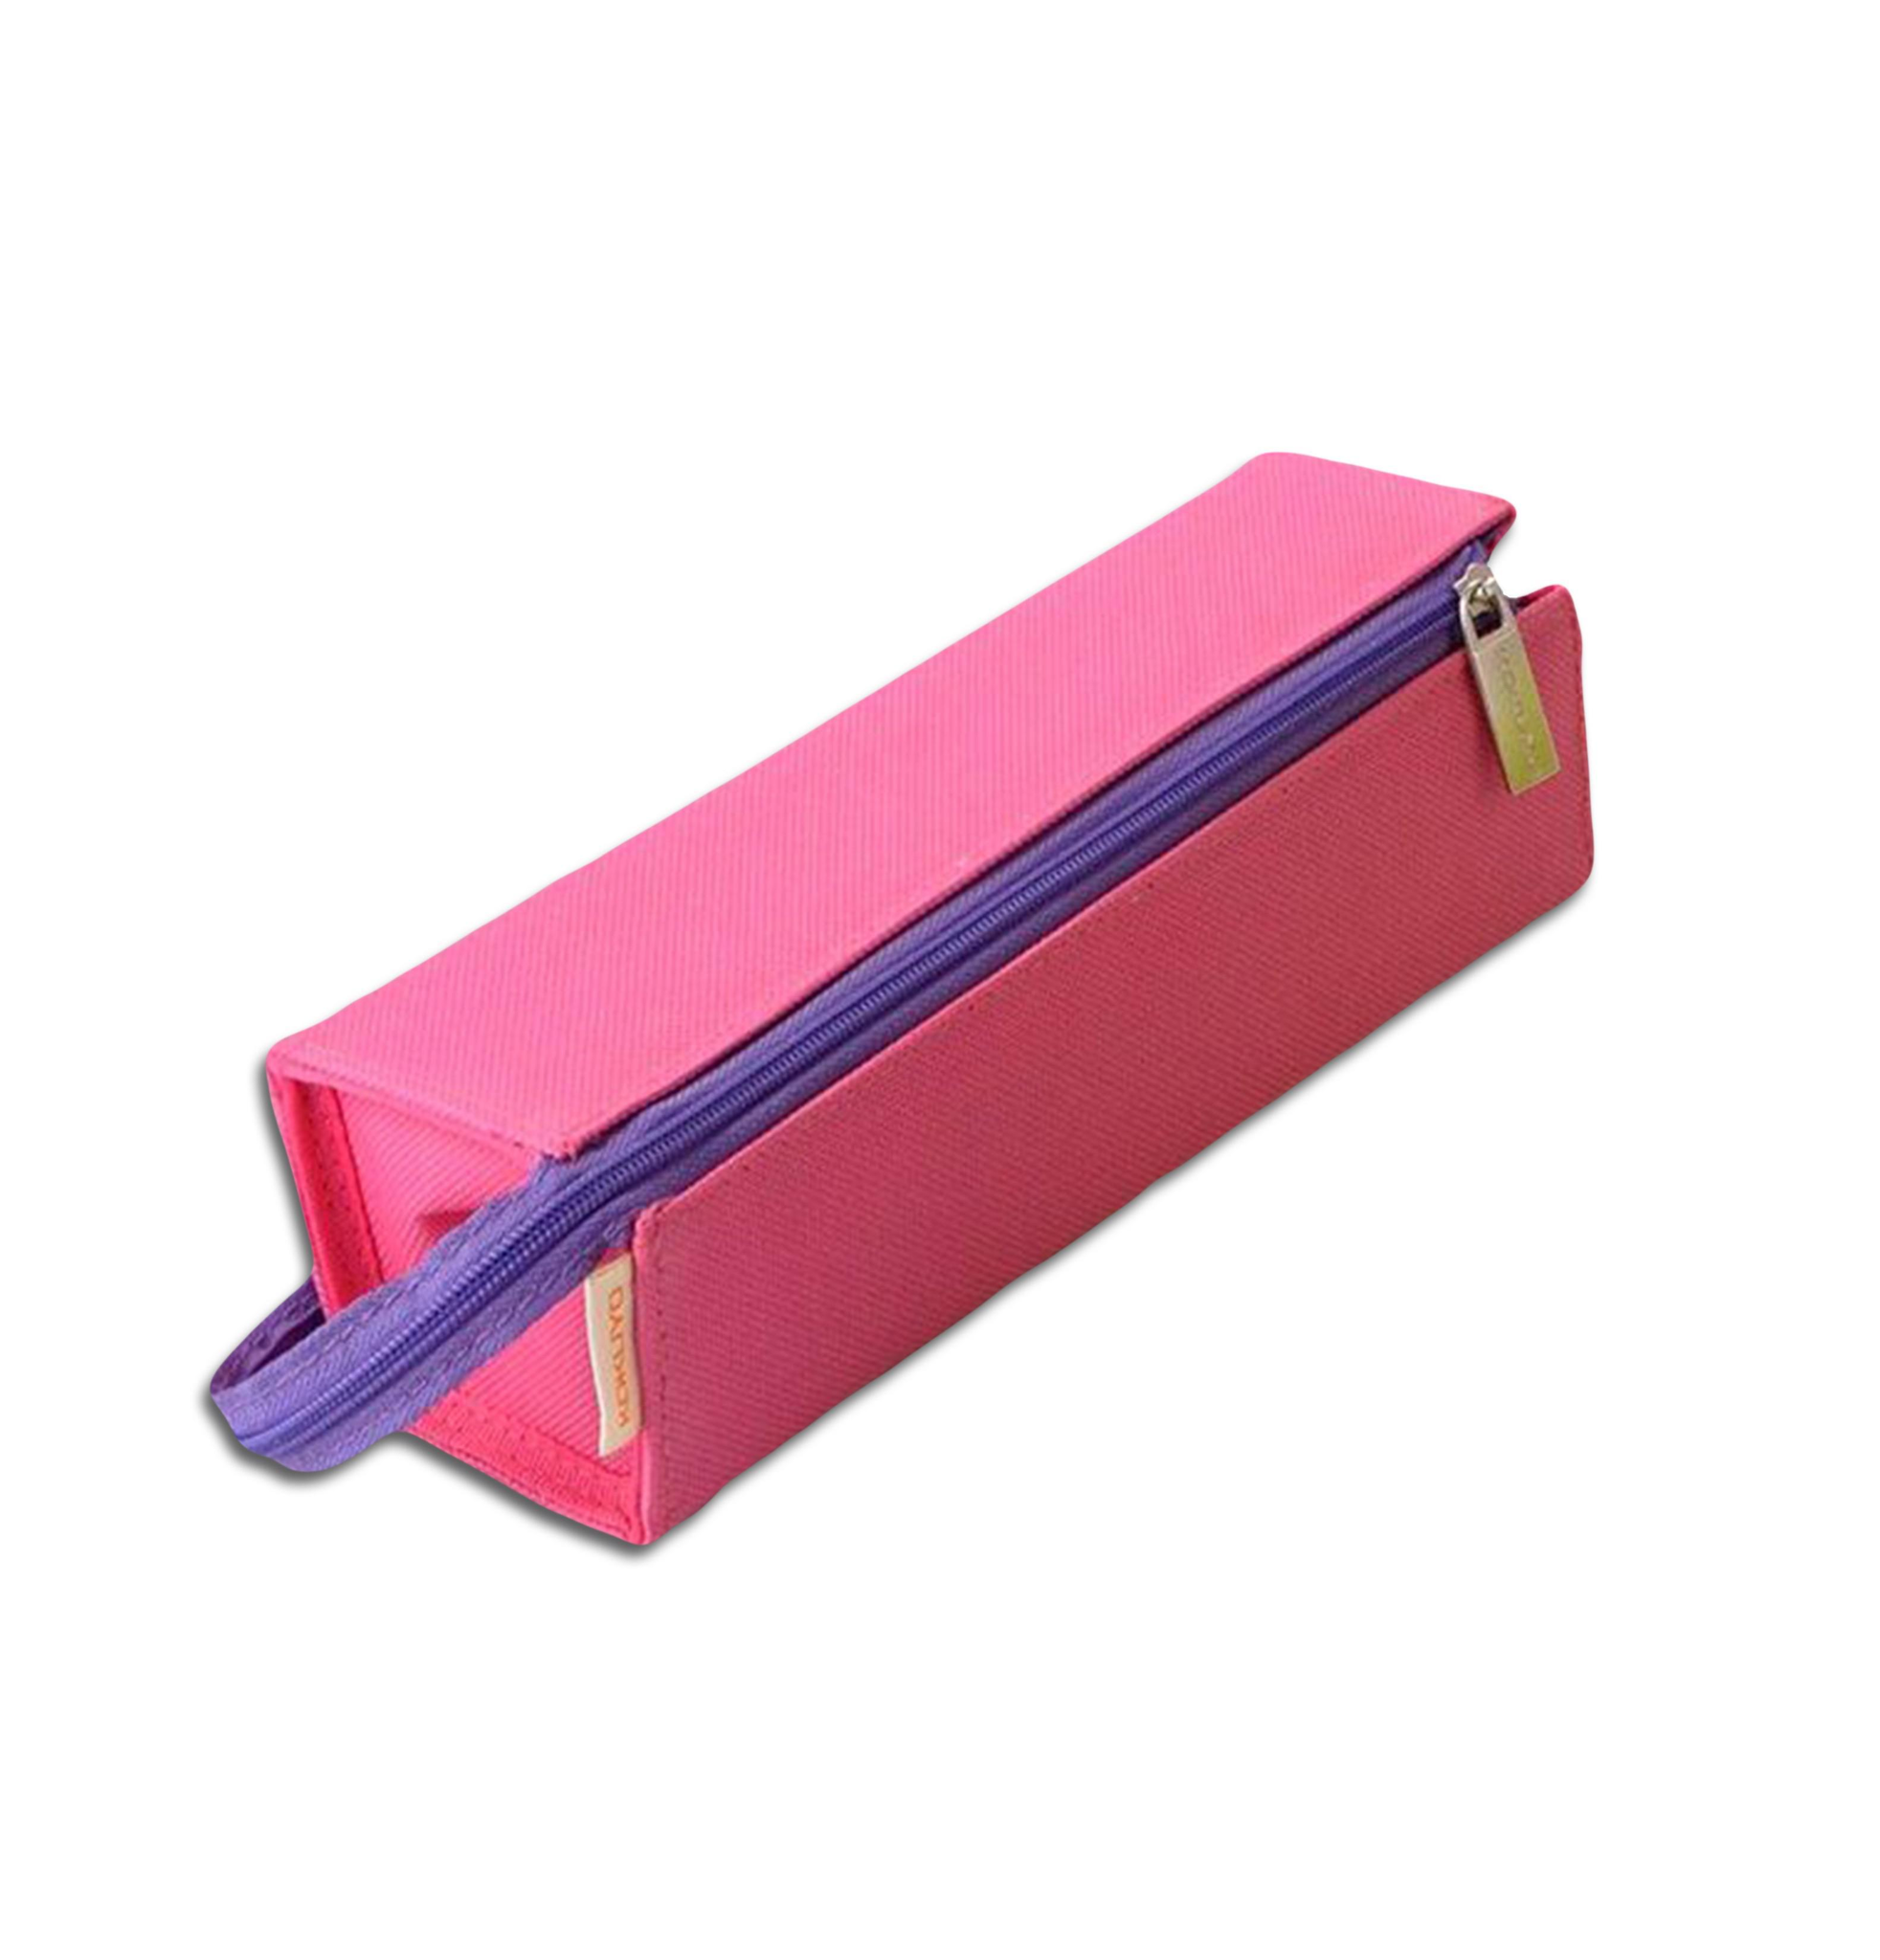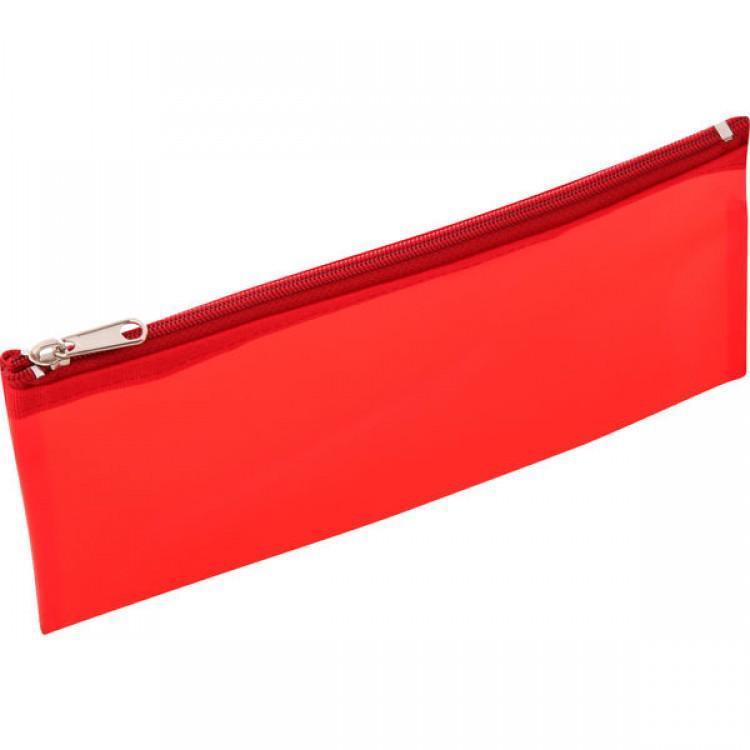The first image is the image on the left, the second image is the image on the right. Examine the images to the left and right. Is the description "The pencil case on the left is not flat; it's shaped more like a rectangular box." accurate? Answer yes or no. Yes. The first image is the image on the left, the second image is the image on the right. Evaluate the accuracy of this statement regarding the images: "There is one brand label showing on the pencil pouch on the right.". Is it true? Answer yes or no. No. 